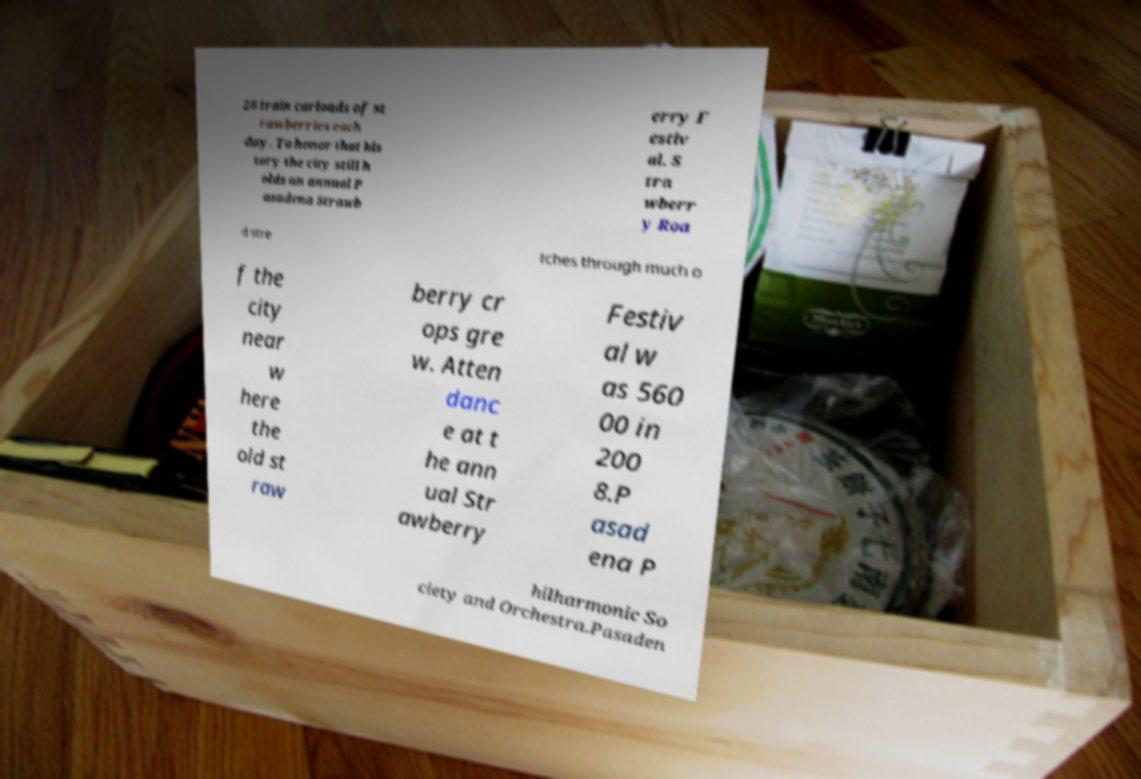There's text embedded in this image that I need extracted. Can you transcribe it verbatim? 28 train carloads of st rawberries each day. To honor that his tory the city still h olds an annual P asadena Strawb erry F estiv al. S tra wberr y Roa d stre tches through much o f the city near w here the old st raw berry cr ops gre w. Atten danc e at t he ann ual Str awberry Festiv al w as 560 00 in 200 8.P asad ena P hilharmonic So ciety and Orchestra.Pasaden 